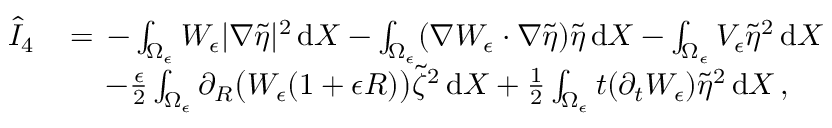<formula> <loc_0><loc_0><loc_500><loc_500>\begin{array} { r l } { \hat { I } _ { 4 } \, } & { = \, - \int _ { \Omega _ { \epsilon } } W _ { \epsilon } | \nabla \tilde { \eta } | ^ { 2 } \, d X - \int _ { \Omega _ { \epsilon } } ( \nabla W _ { \epsilon } \cdot \nabla \tilde { \eta } ) \tilde { \eta } \, d X - \int _ { \Omega _ { \epsilon } } V _ { \epsilon } \tilde { \eta } ^ { 2 } \, d X } \\ & { \quad \, - \frac { \epsilon } { 2 } \int _ { \Omega _ { \epsilon } } \partial _ { R } \left ( W _ { \epsilon } ( 1 + \epsilon R ) \right ) \tilde { \zeta } ^ { 2 } \, d X + \frac { 1 } { 2 } \int _ { \Omega _ { \epsilon } } t ( \partial _ { t } W _ { \epsilon } ) \tilde { \eta } ^ { 2 } \, d X \, , } \end{array}</formula> 